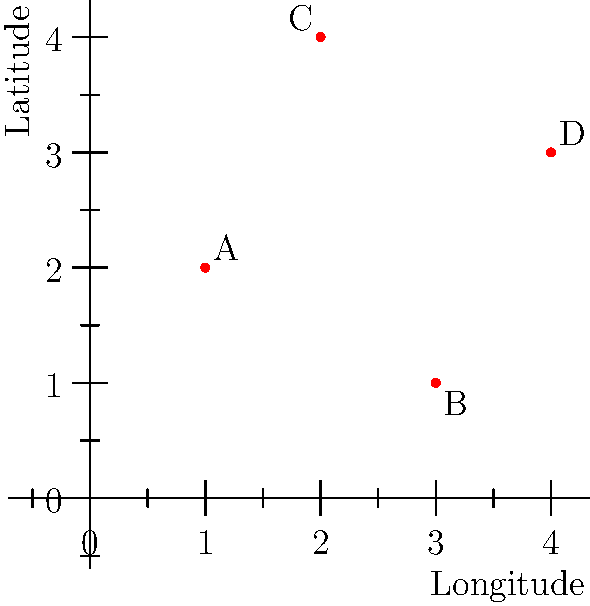A coastal map shows four popular surf spots (A, B, C, and D) plotted using latitude and longitude coordinates. Which surf spot is located at approximately (3°E, 1°N)? To answer this question, we need to interpret the coordinate system and identify the correct surf spot:

1. The x-axis represents longitude (East-West direction), and the y-axis represents latitude (North-South direction).
2. The question asks for the spot at (3°E, 1°N), so we're looking for a point at x=3 and y=1.
3. Examining the plot:
   - Spot A is at approximately (1°E, 2°N)
   - Spot B is at approximately (3°E, 1°N)
   - Spot C is at approximately (2°E, 4°N)
   - Spot D is at approximately (4°E, 3°N)
4. The coordinates (3°E, 1°N) match the location of Spot B.

Therefore, the surf spot located at approximately (3°E, 1°N) is Spot B.
Answer: B 